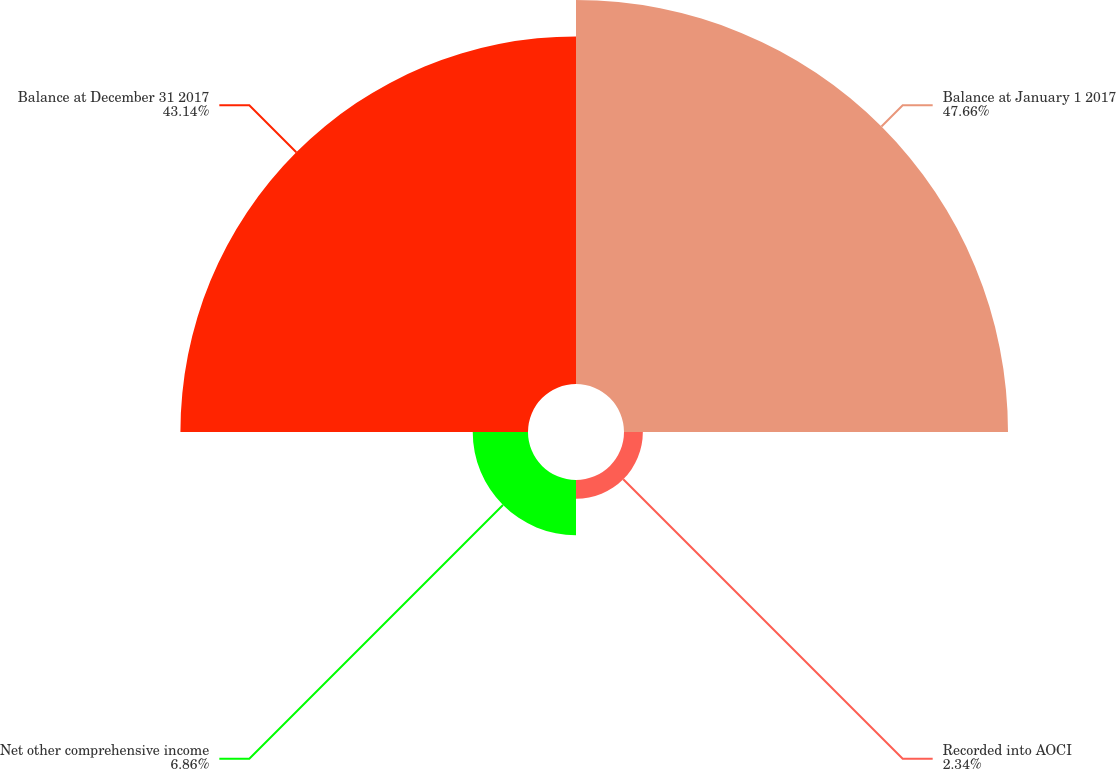Convert chart to OTSL. <chart><loc_0><loc_0><loc_500><loc_500><pie_chart><fcel>Balance at January 1 2017<fcel>Recorded into AOCI<fcel>Net other comprehensive income<fcel>Balance at December 31 2017<nl><fcel>47.66%<fcel>2.34%<fcel>6.86%<fcel>43.14%<nl></chart> 